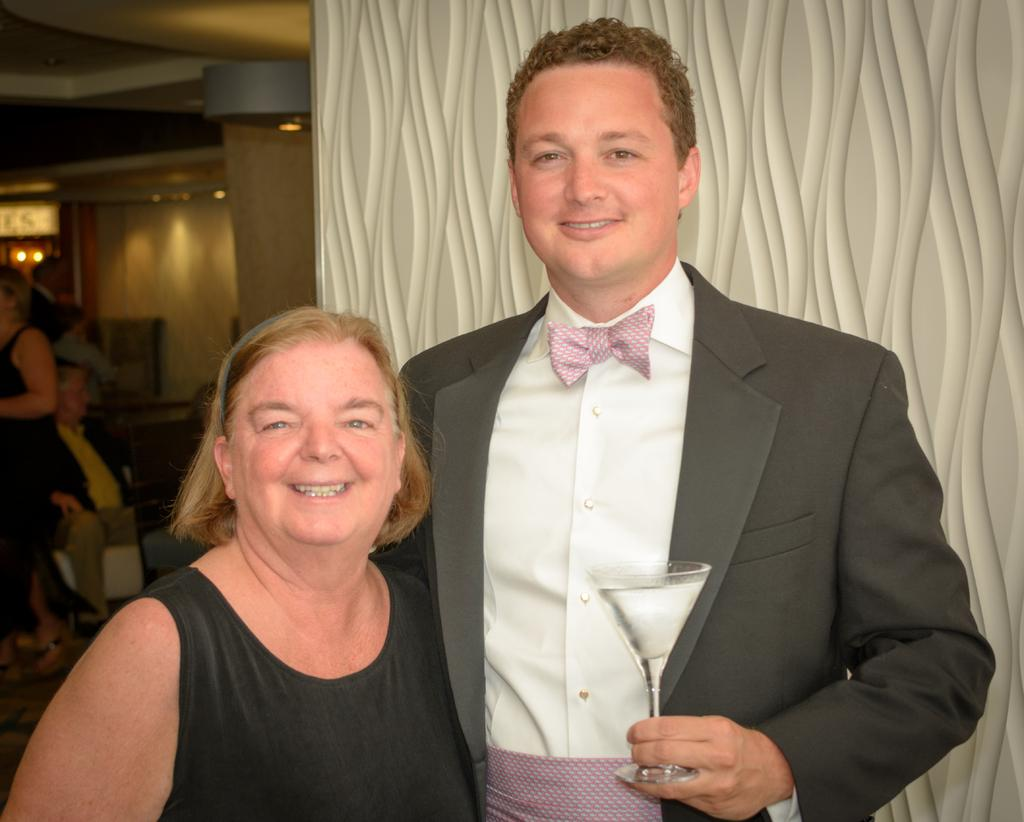What is the man in the image holding? The man is holding a glass in the image. Can you describe the position of the woman in relation to the man? The woman is behind the man in the image. How many people are present in the image? There are two people in the image, a man and a woman. What time is displayed on the credit card in the image? There is no credit card present in the image, so it is not possible to determine the time displayed on it. 